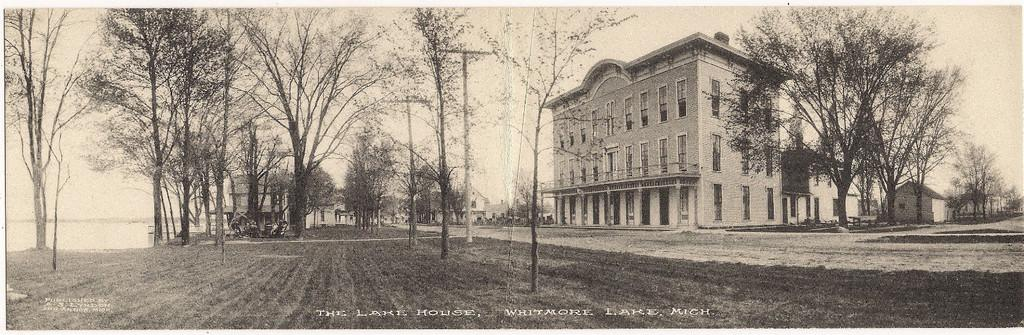What is located in the middle of the image? There are trees in the middle of the image. What type of structures can be seen on the right side of the image? There are buildings on the right side of the image. What is written or depicted at the bottom of the image? There is text at the bottom of the image. What color scheme is used in the image? The image is in black and white color. What type of apparatus is being used to rest the trees in the image? There is no apparatus present in the image, and the trees are not being rested on anything. 